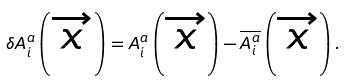<formula> <loc_0><loc_0><loc_500><loc_500>\delta A _ { i } ^ { a } \left ( \overrightarrow { x } \right ) = A _ { i } ^ { a } \left ( \overrightarrow { x } \right ) - \overline { A _ { i } ^ { a } } \left ( \overrightarrow { x } \right ) .</formula> 